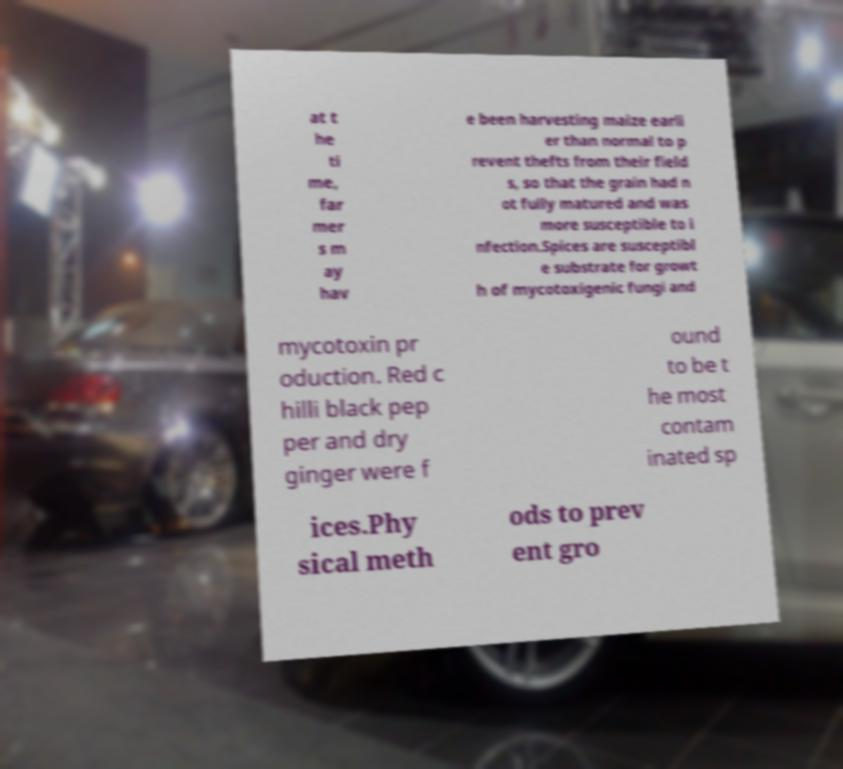Can you accurately transcribe the text from the provided image for me? at t he ti me, far mer s m ay hav e been harvesting maize earli er than normal to p revent thefts from their field s, so that the grain had n ot fully matured and was more susceptible to i nfection.Spices are susceptibl e substrate for growt h of mycotoxigenic fungi and mycotoxin pr oduction. Red c hilli black pep per and dry ginger were f ound to be t he most contam inated sp ices.Phy sical meth ods to prev ent gro 